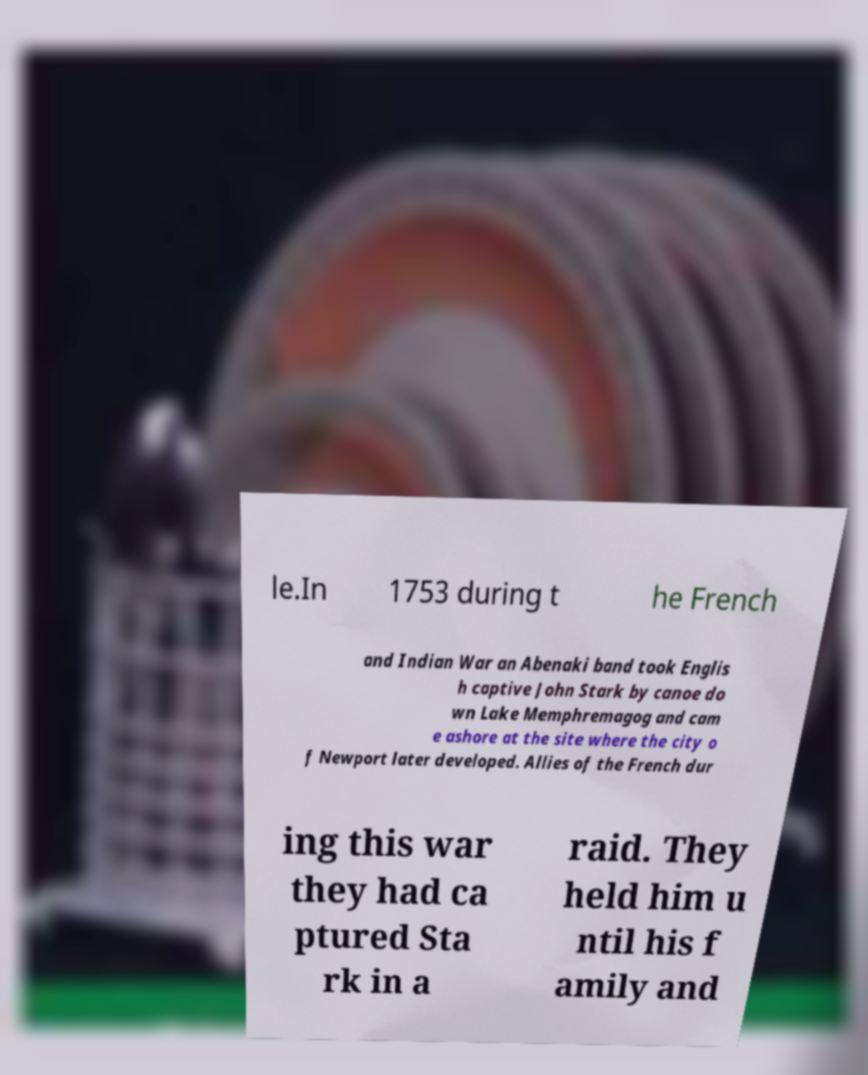What messages or text are displayed in this image? I need them in a readable, typed format. le.In 1753 during t he French and Indian War an Abenaki band took Englis h captive John Stark by canoe do wn Lake Memphremagog and cam e ashore at the site where the city o f Newport later developed. Allies of the French dur ing this war they had ca ptured Sta rk in a raid. They held him u ntil his f amily and 